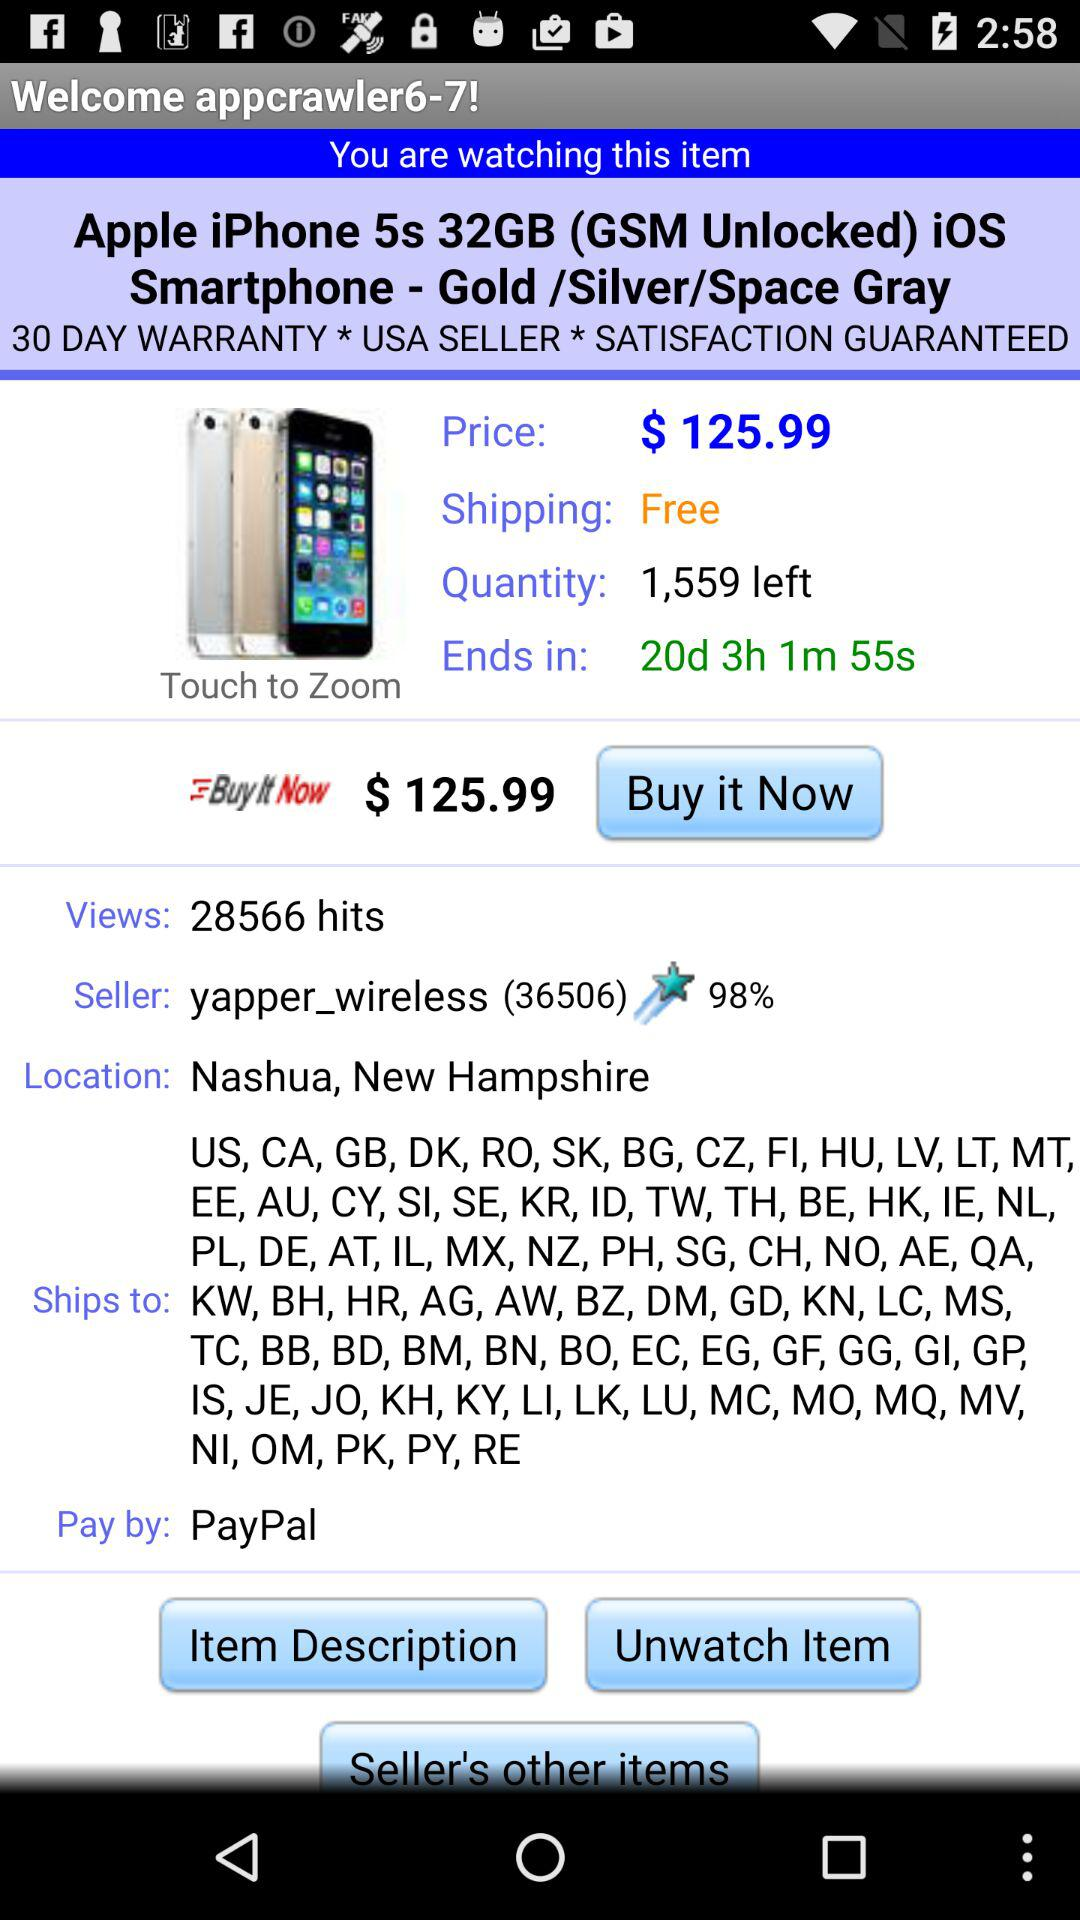What is the user profile name? The user profile name is "appcrawler6-7". 